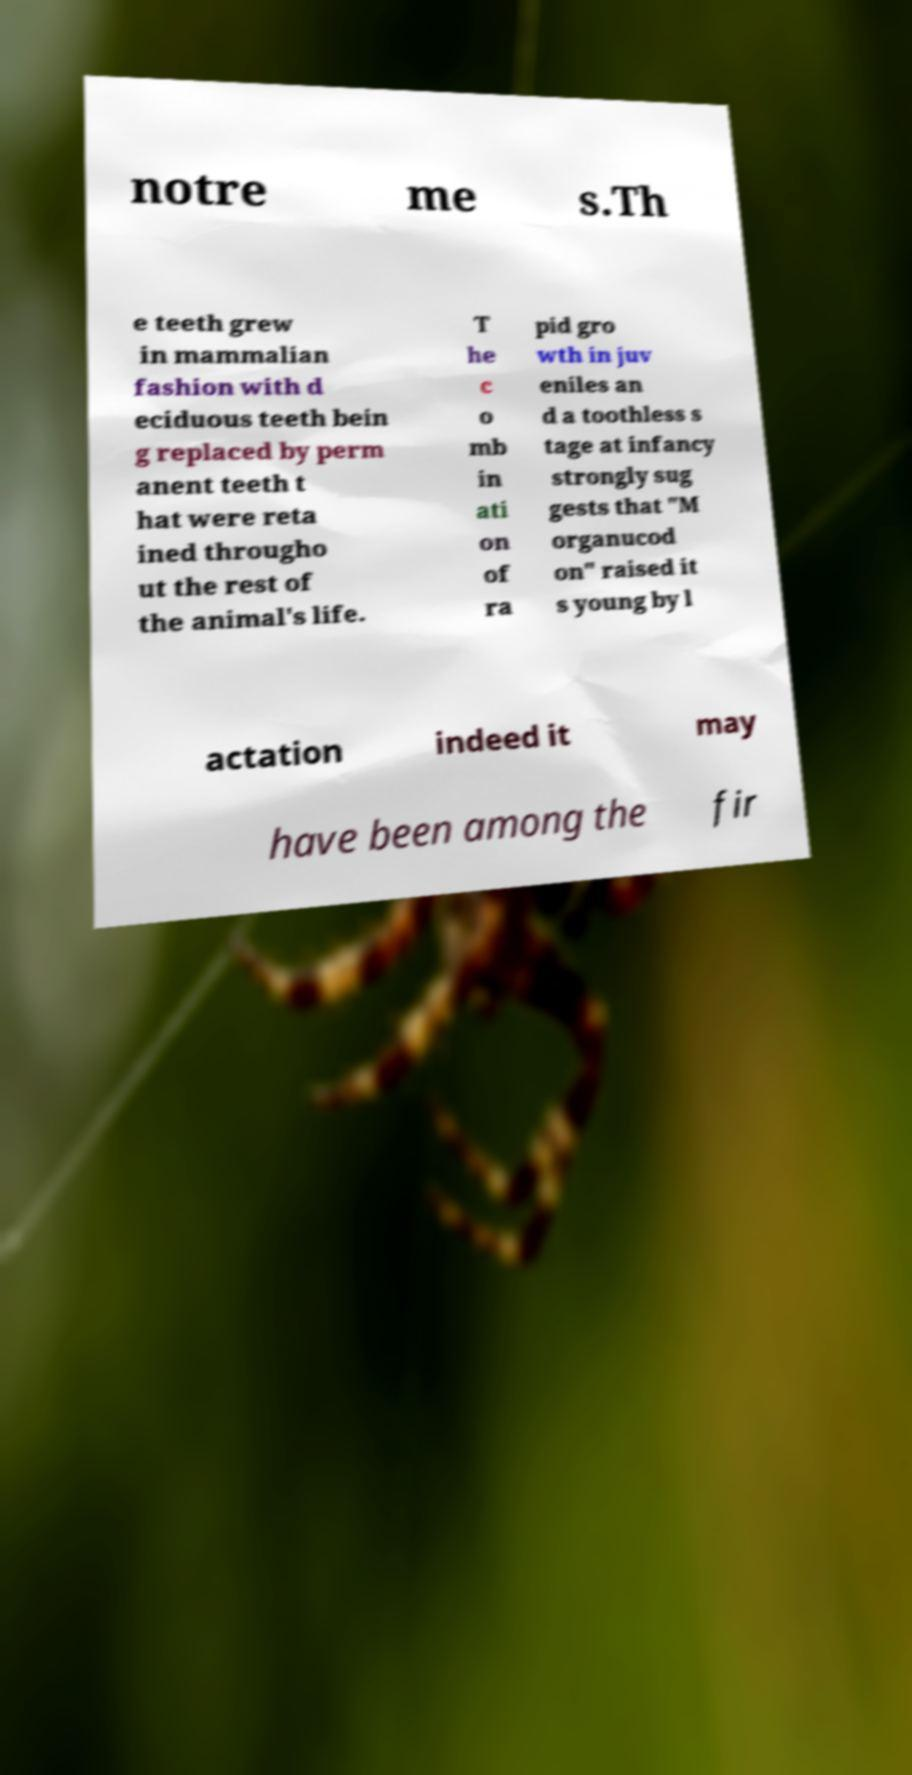Can you accurately transcribe the text from the provided image for me? notre me s.Th e teeth grew in mammalian fashion with d eciduous teeth bein g replaced by perm anent teeth t hat were reta ined througho ut the rest of the animal's life. T he c o mb in ati on of ra pid gro wth in juv eniles an d a toothless s tage at infancy strongly sug gests that "M organucod on" raised it s young by l actation indeed it may have been among the fir 